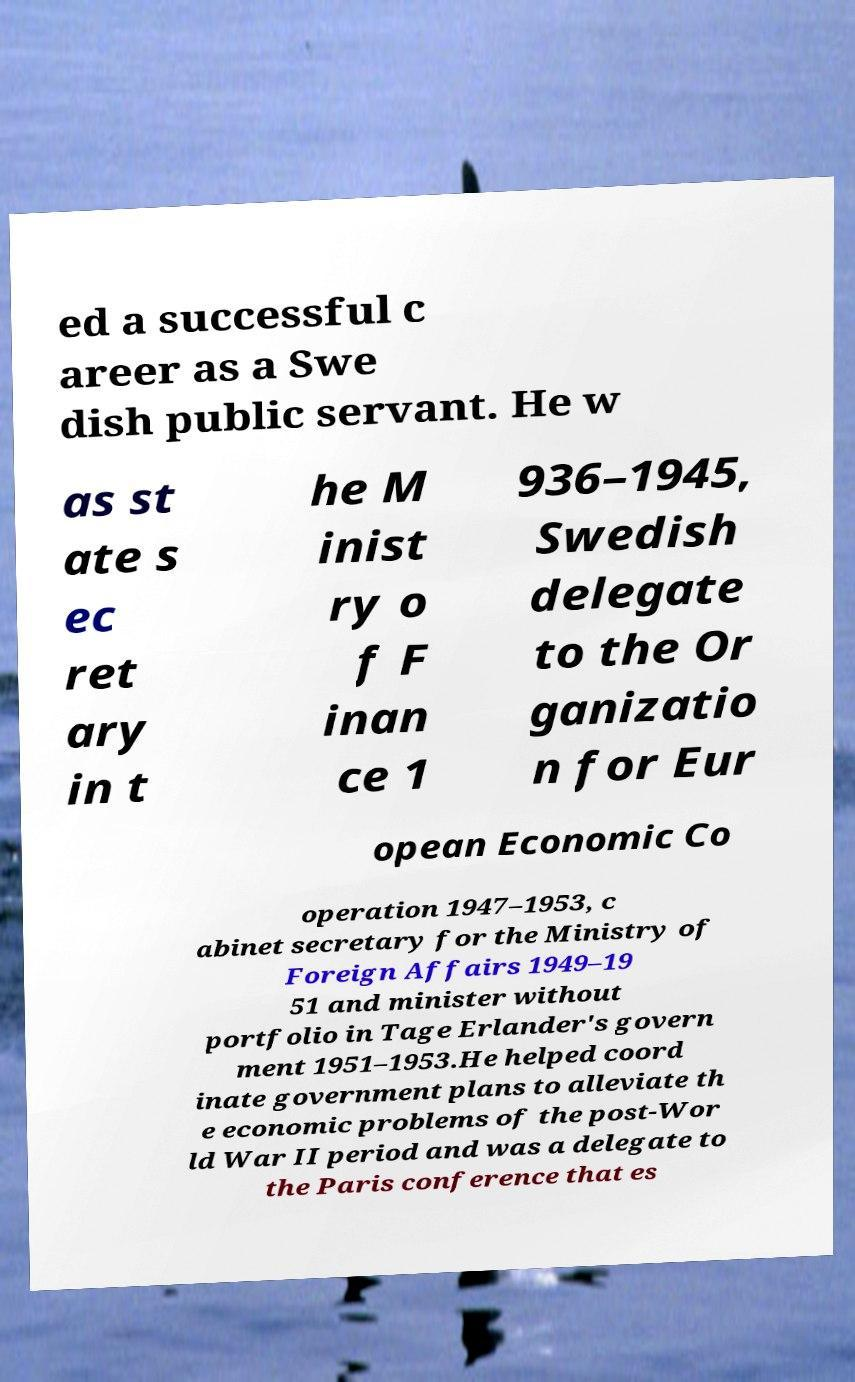Please identify and transcribe the text found in this image. ed a successful c areer as a Swe dish public servant. He w as st ate s ec ret ary in t he M inist ry o f F inan ce 1 936–1945, Swedish delegate to the Or ganizatio n for Eur opean Economic Co operation 1947–1953, c abinet secretary for the Ministry of Foreign Affairs 1949–19 51 and minister without portfolio in Tage Erlander's govern ment 1951–1953.He helped coord inate government plans to alleviate th e economic problems of the post-Wor ld War II period and was a delegate to the Paris conference that es 